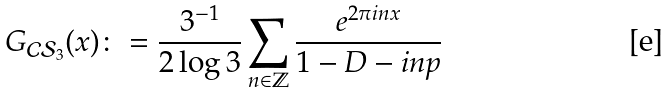<formula> <loc_0><loc_0><loc_500><loc_500>G _ { \mathcal { C S } _ { 3 } } ( x ) \colon = \frac { 3 ^ { - 1 } } { 2 \log 3 } \sum _ { n \in \mathbb { Z } } \frac { e ^ { 2 \pi i n x } } { 1 - D - i n p }</formula> 